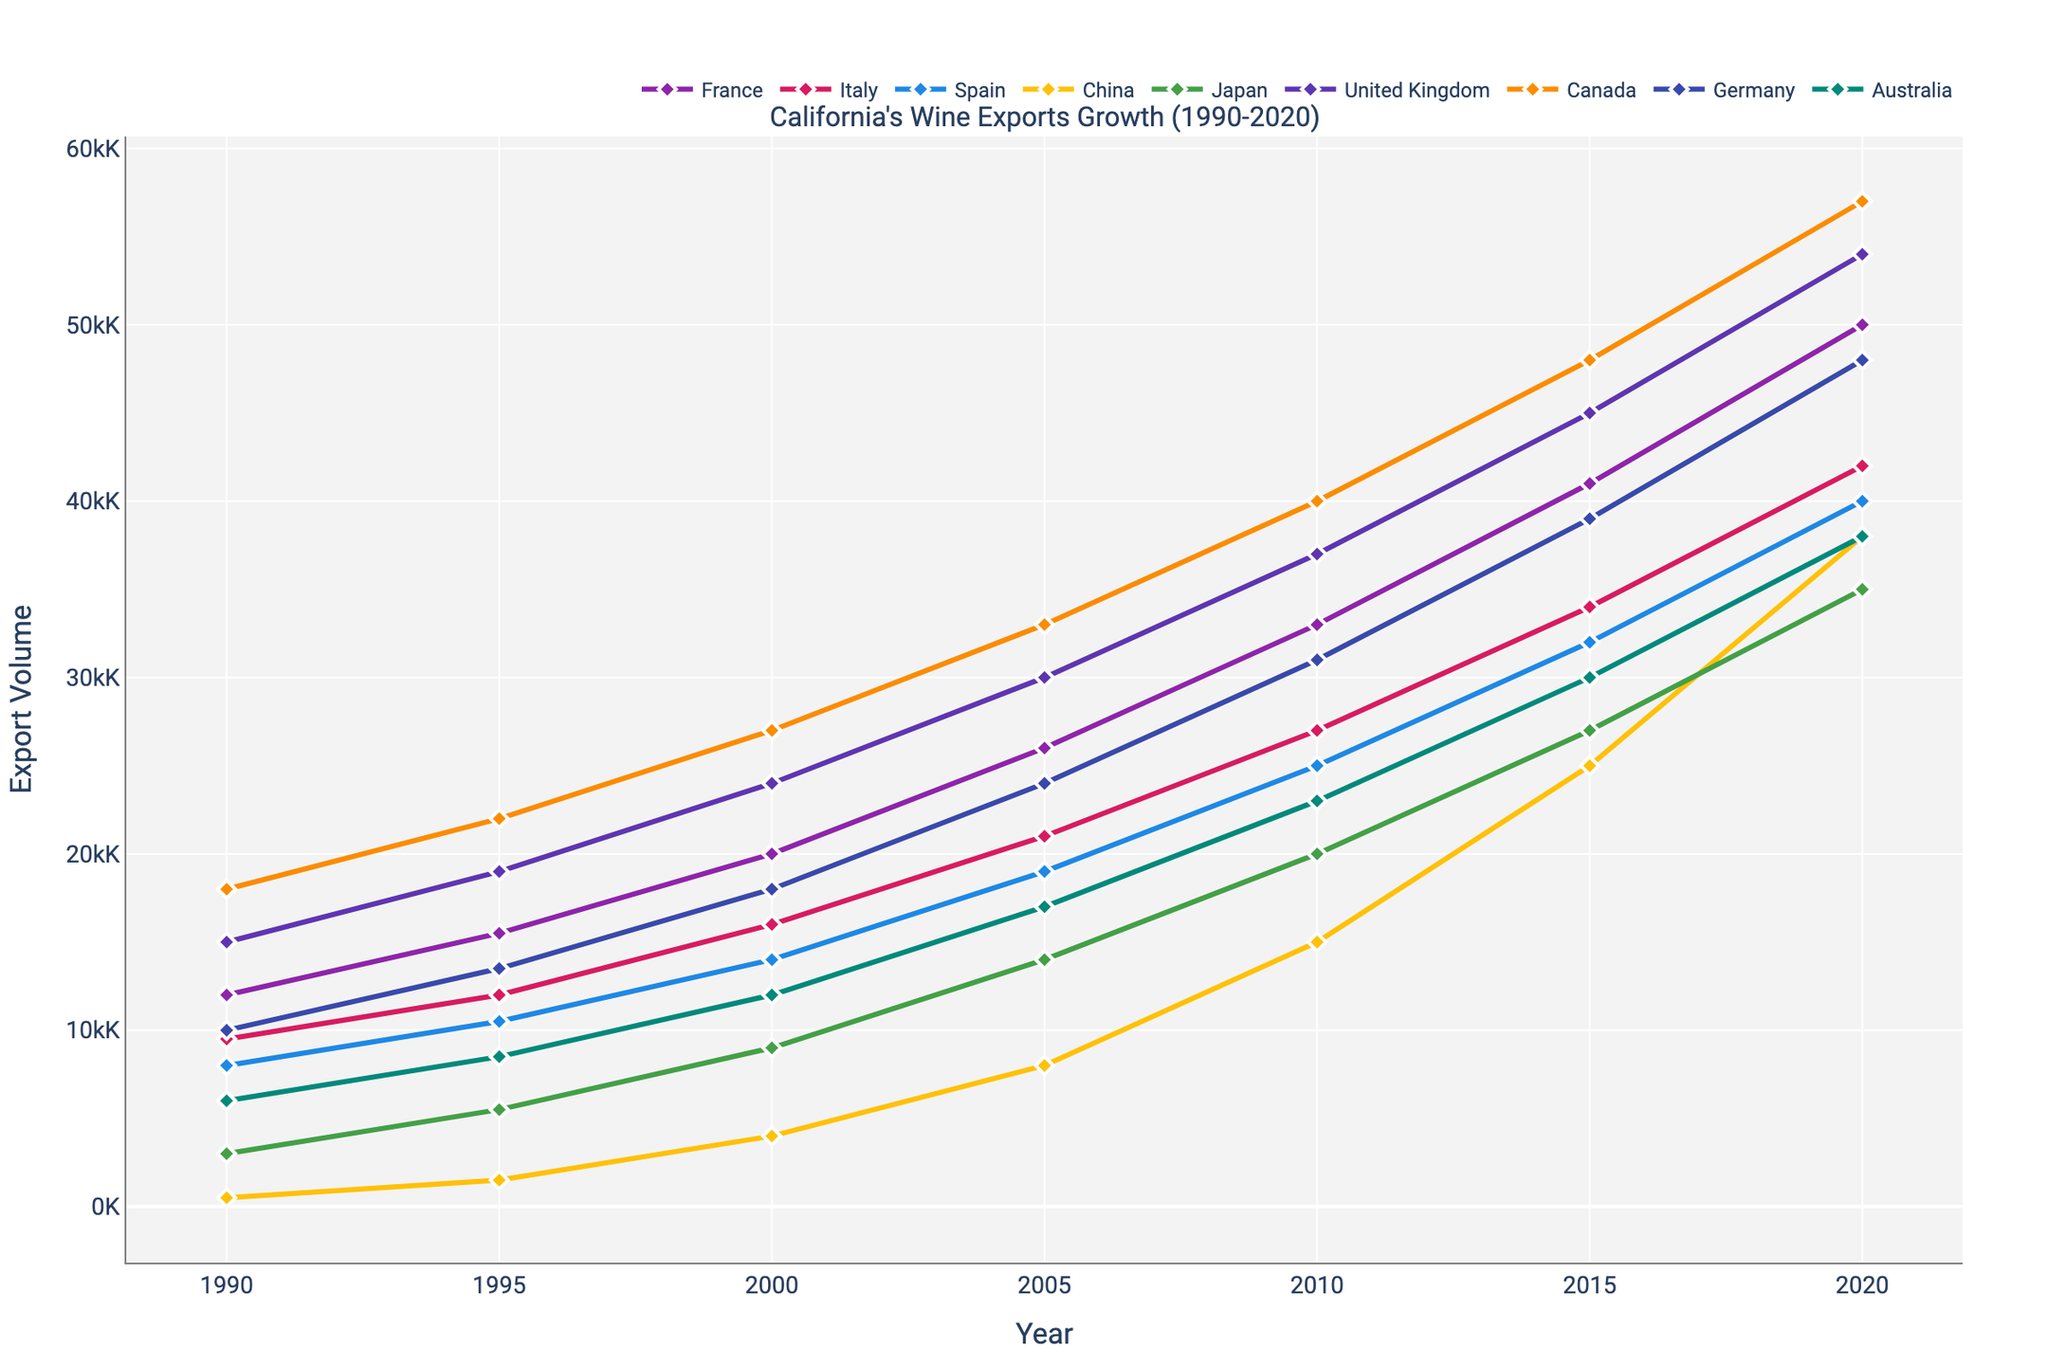What year did Japan start importing more than 20,000K California wine? Locate Japan's export data and identify the first year it exceeds 20,000K. This happens in 2010.
Answer: 2010 By how much did wine exports to China increase from 1990 to 2020? In 1990, exports to China were at 500K. By 2020, this number increased to 38,000K. The difference is computed as 38,000K - 500K = 37,500K.
Answer: 37,500K Which country had the largest relative increase in wine imports between 1990 and 2020? To determine this, calculate the relative increase for each country: (value in 2020 - value in 1990) / value in 1990. China has the largest increase from 500K in 1990 to 38,000K in 2020. Relative increase = (38,000 - 500) / 500 = 75.
Answer: China Which country imported the most California wine in 1995? Look at the 1995 data and compare values for each country. The UK imported the most with 19,000K.
Answer: United Kingdom How does the growth of wine exports to Australia compare to Germany between 1990 and 2020? For Australia, the exports increased from 6,000K to 38,000K. For Germany, they increased from 10,000K to 48,000K. Comparing the two, the growth for Germany is higher by 48,000K - 38,000K = 10,000K.
Answer: Germany Which country shows the most stable growth in wine imports from 1990 to 2020? Observe the trends for each country. Canada shows a consistent upward trend without significant fluctuations.
Answer: Canada What visual marker shapes are used to denote the data points in the chart? Identify the marker shape used across all data points. They are diamond-shaped markers.
Answer: Diamond During which five-year period did France's wine imports grow the most? Measure the increase between consecutive five-year intervals. The largest growth for France is from 2010 to 2015, with an increase from 33,000K to 41,000K, a growth of 8,000K.
Answer: 2010-2015 What color represents the wine exports to Italy in the chart? Find the trace for Italy and identify the color used, which is a shade of red.
Answer: Red 